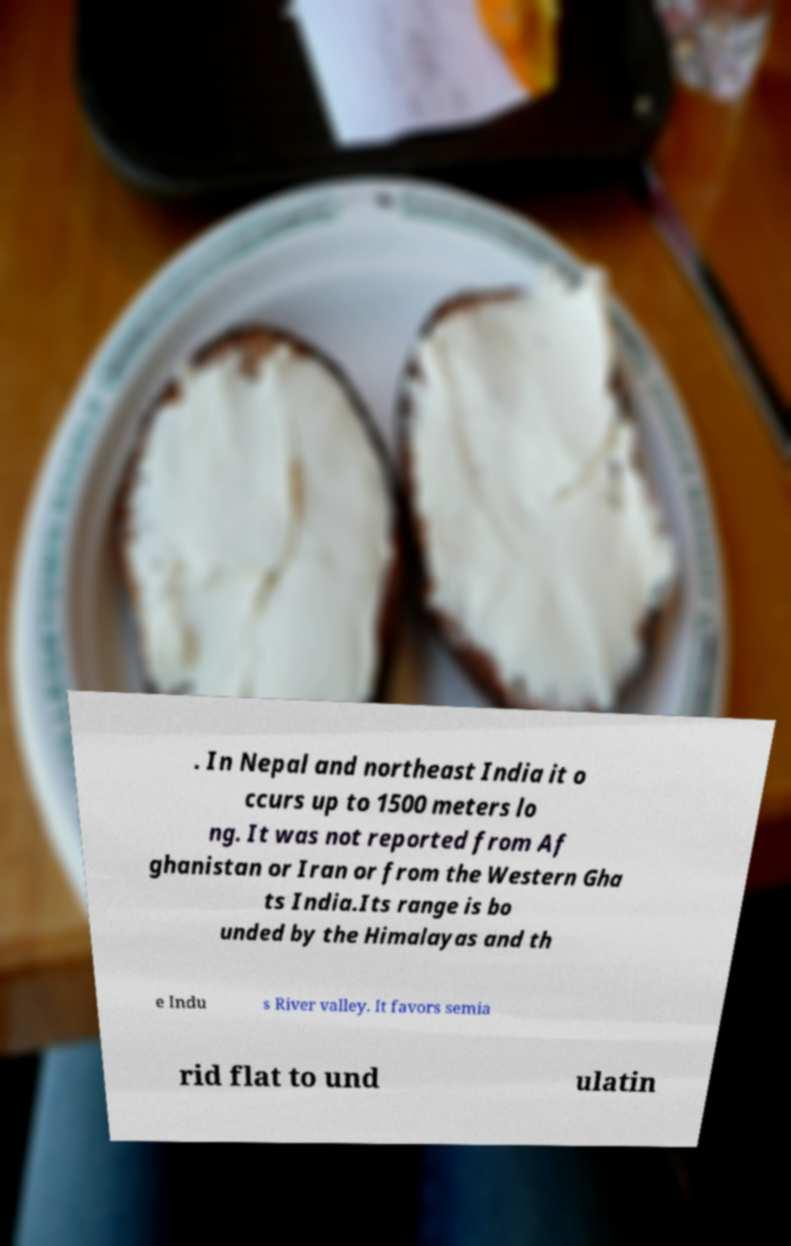For documentation purposes, I need the text within this image transcribed. Could you provide that? . In Nepal and northeast India it o ccurs up to 1500 meters lo ng. It was not reported from Af ghanistan or Iran or from the Western Gha ts India.Its range is bo unded by the Himalayas and th e Indu s River valley. It favors semia rid flat to und ulatin 